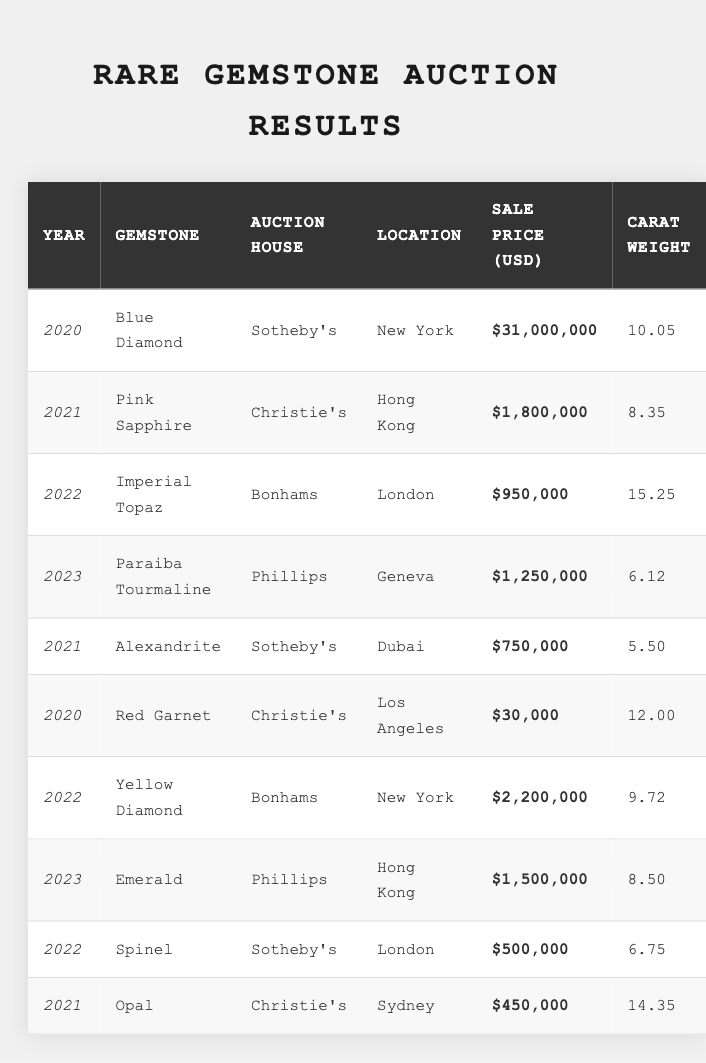What gemstone sold for the highest price in 2020? The 2020 auction results show that the Blue Diamond was sold for $31,000,000, which is the highest price listed for that year.
Answer: Blue Diamond How much was the Pink Sapphire sold for at auction in 2021? The sale price for the Pink Sapphire at Christie's in Hong Kong in 2021 was $1,800,000, as shown in the table.
Answer: $1,800,000 What is the carat weight of the Yellow Diamond sold in 2022? Looking at the 2022 auction results, the Yellow Diamond had a carat weight of 9.72, listed under Bonhams in New York.
Answer: 9.72 Which auction house sold the Emerald in 2023? Referring to the 2023 results, the Emerald was sold by Phillips in Hong Kong.
Answer: Phillips Is there any Alexandrite auctioned in 2022? The table indicates that there is no entry for Alexandrite in 2022; it was auctioned only in 2021 by Sotheby's.
Answer: No What is the average sale price of gemstones sold in 2021? First, identify the sale prices for 2021: Pink Sapphire ($1,800,000), Alexandrite ($750,000), and Opal ($450,000). Then, calculate the average as follows: (1,800,000 + 750,000 + 450,000) / 3 = $1,333,333.33.
Answer: $1,333,333.33 In what year was the Imperial Topaz sold? The auction records show that the Imperial Topaz was sold in 2022, during its listing under Bonhams in London.
Answer: 2022 How many carats did the Red Garnet weigh when sold? According to the auction results, the Red Garnet sold in 2020 had a carat weight of 12.00.
Answer: 12.00 Which gemstone had the lowest sale price in 2020? The auction results for 2020 show that the Red Garnet sold for $30,000, which is the lowest sale price for that year.
Answer: Red Garnet What is the total sale price of gemstones auctioned in 2023? To find the total for 2023, sum the prices of the Paraiba Tourmaline ($1,250,000) and Emerald ($1,500,000): $1,250,000 + $1,500,000 = $2,750,000.
Answer: $2,750,000 